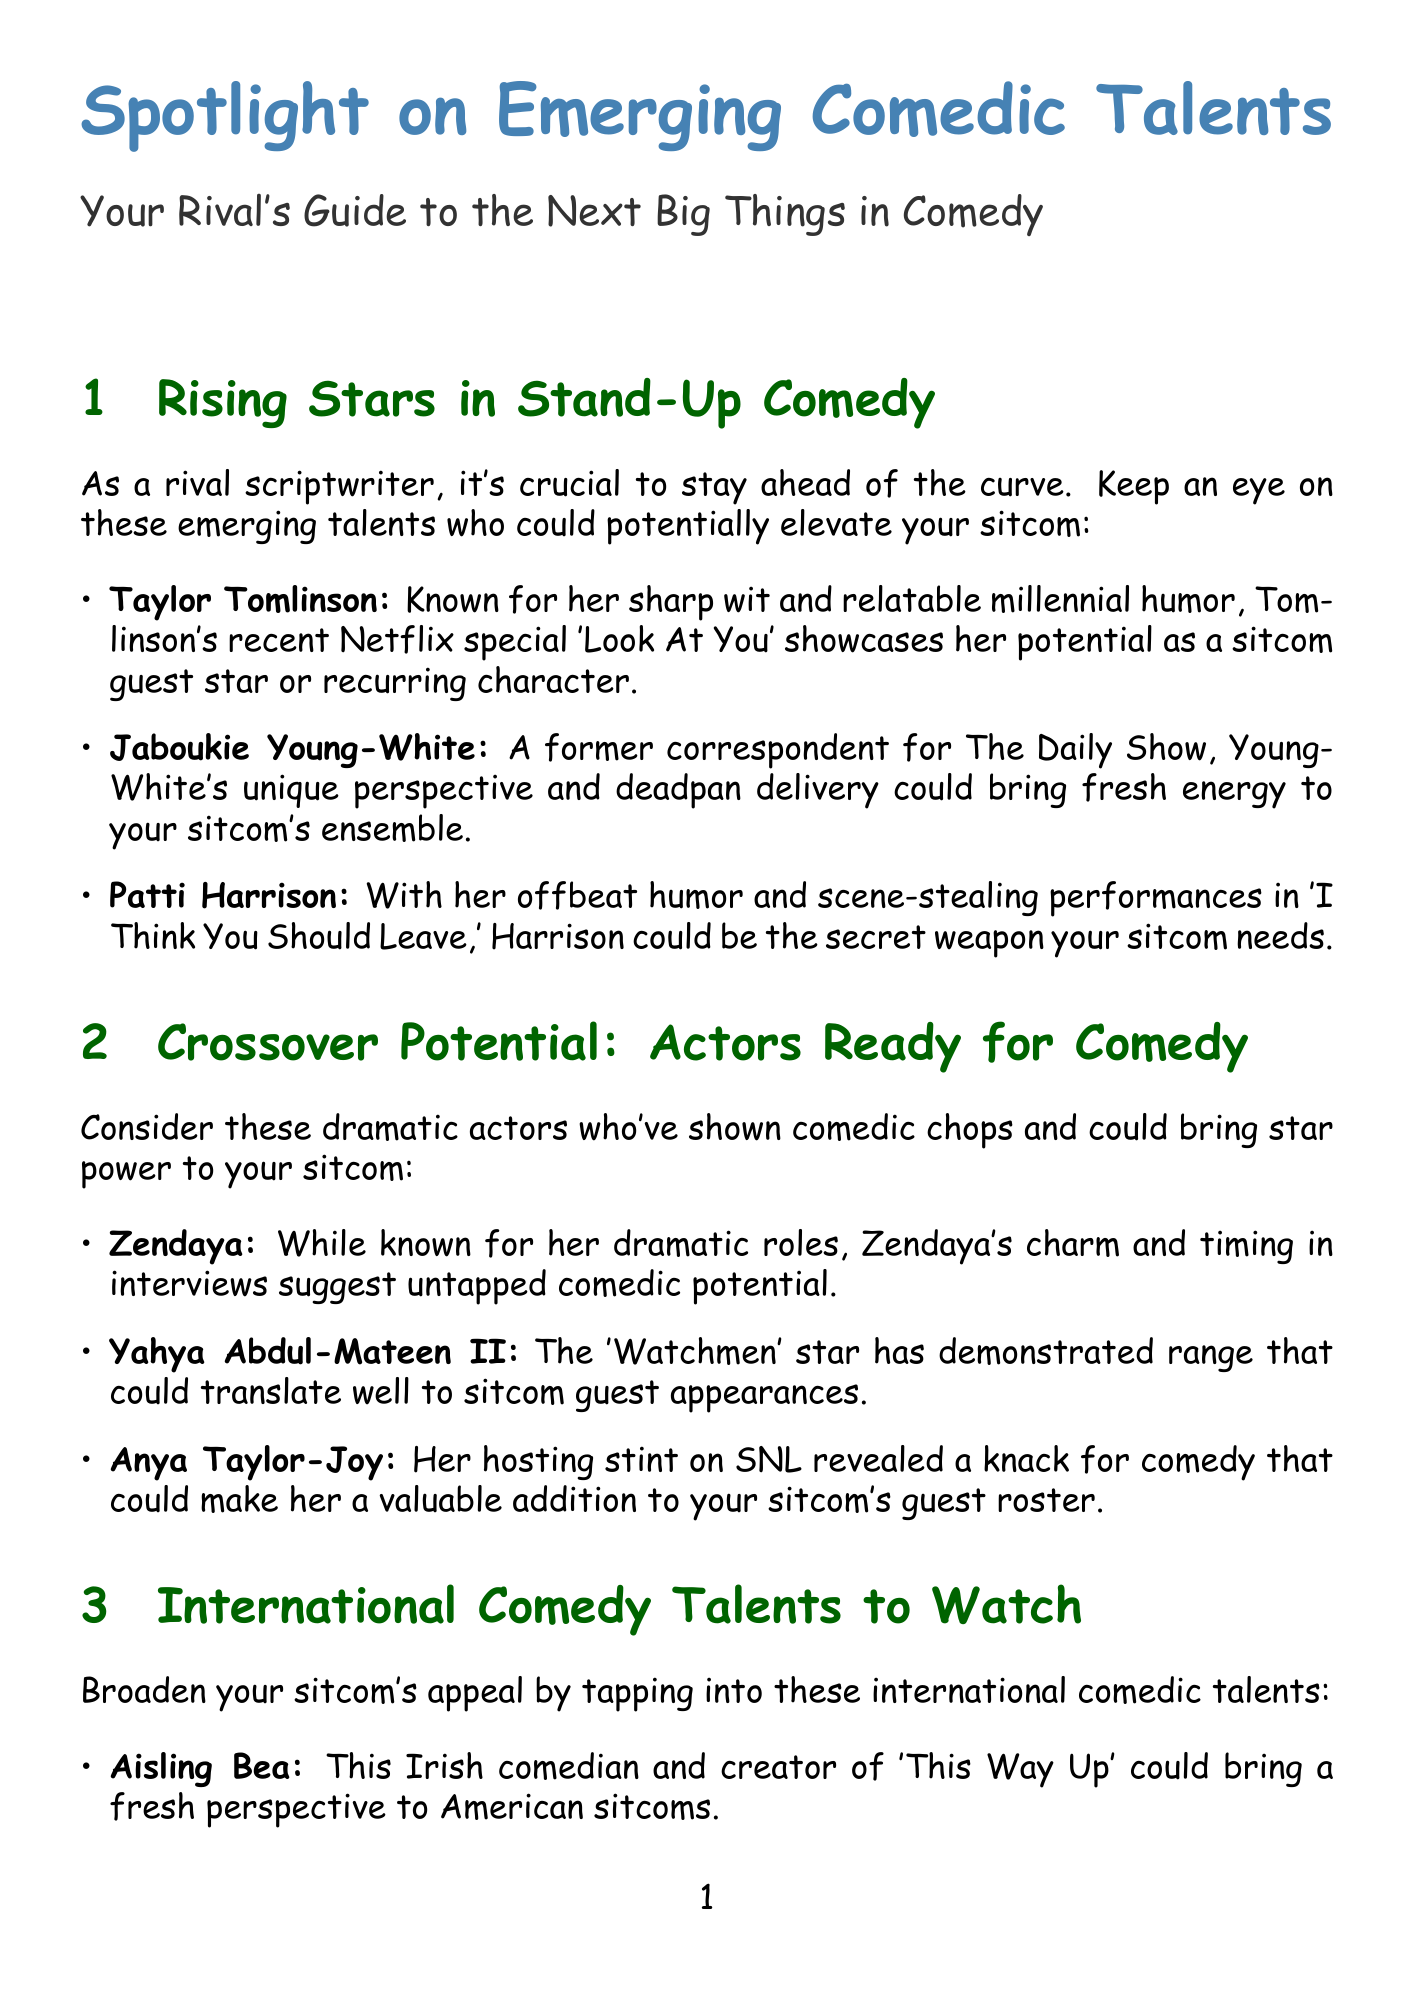what is the name of the comedian known for her sharp wit? The document states that Taylor Tomlinson is known for her sharp wit and relatable millennial humor.
Answer: Taylor Tomlinson which actor's charm suggests untapped comedic potential? According to the document, Zendaya's charm and timing in interviews suggest untapped comedic potential.
Answer: Zendaya who is the Australian comedian mentioned in the document? Claudia O'Doherty is identified as the Australian comedian known for 'Love' and 'Trainwreck.'
Answer: Claudia O'Doherty how many viral sensations are listed in the document? The document includes three viral sensations ready for prime time.
Answer: Three which stand-up comedian's performance is showcased in a Netflix special? The document notes that Taylor Tomlinson's recent Netflix special 'Look At You' showcases her potential.
Answer: Taylor Tomlinson name one comedic writer mentioned who has her own show. Amber Ruffin is a writer for 'Late Night with Seth Meyers' and host of her own show.
Answer: Amber Ruffin which international comedian is from Ireland? Aisling Bea is noted as an Irish comedian and creator of 'This Way Up.'
Answer: Aisling Bea who is known for their character work and impressions on social media? Benito Skinner, also known as Benny Drama, is recognized for his character work and impressions on Instagram and TikTok.
Answer: Benito Skinner (Benny Drama) what title is given to the section discussing dramatic actors with comedic potential? The title for that section is "Crossover Potential: Actors Ready for Comedy."
Answer: Crossover Potential: Actors Ready for Comedy 